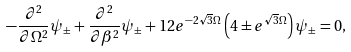Convert formula to latex. <formula><loc_0><loc_0><loc_500><loc_500>- \frac { \partial ^ { 2 } } { \partial \Omega ^ { 2 } } \psi _ { \pm } + \frac { \partial ^ { 2 } } { \partial \beta ^ { 2 } } \psi _ { \pm } + 1 2 e ^ { - 2 \sqrt { 3 } \Omega } \left ( 4 \pm e ^ { \sqrt { 3 } \Omega } \right ) \psi _ { \pm } = 0 ,</formula> 